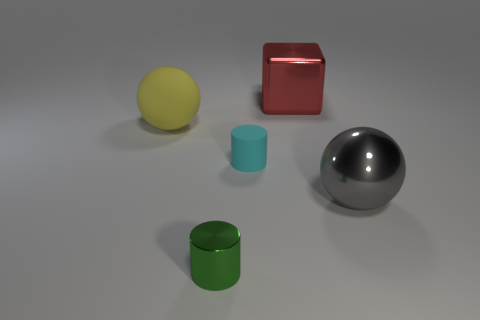Add 5 big yellow matte objects. How many objects exist? 10 Subtract all balls. How many objects are left? 3 Subtract all green things. Subtract all tiny cyan things. How many objects are left? 3 Add 3 gray spheres. How many gray spheres are left? 4 Add 5 large gray shiny spheres. How many large gray shiny spheres exist? 6 Subtract 0 gray cubes. How many objects are left? 5 Subtract 2 spheres. How many spheres are left? 0 Subtract all cyan cylinders. Subtract all red spheres. How many cylinders are left? 1 Subtract all red cylinders. How many green cubes are left? 0 